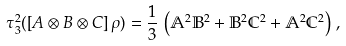<formula> <loc_0><loc_0><loc_500><loc_500>\tau _ { 3 } ^ { 2 } ( \left [ A \otimes B \otimes C \right ] \rho ) = \frac { 1 } { 3 } \, \left ( \mathbb { A } ^ { 2 } \mathbb { B } ^ { 2 } + \mathbb { B } ^ { 2 } \mathbb { C } ^ { 2 } + \mathbb { A } ^ { 2 } \mathbb { C } ^ { 2 } \right ) \, ,</formula> 